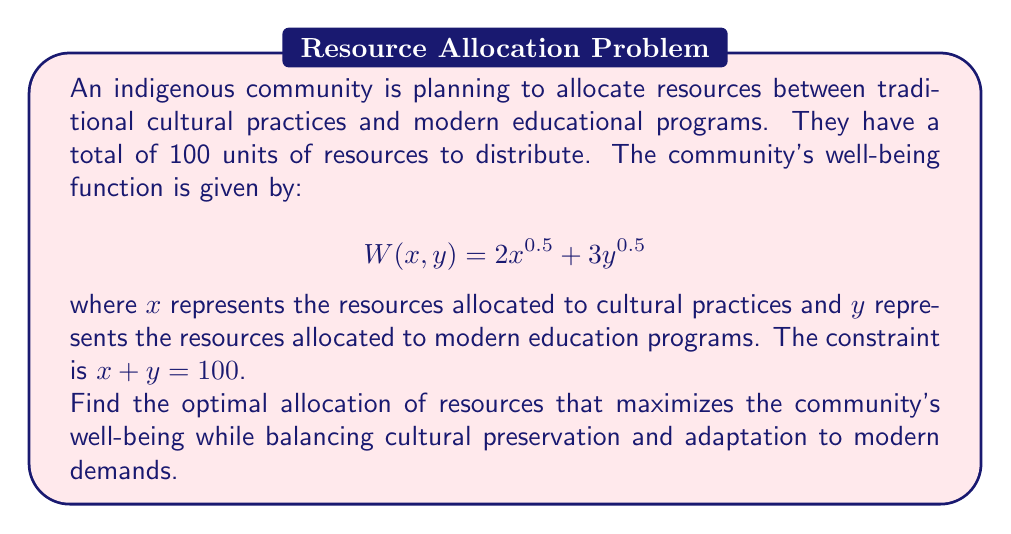Can you answer this question? To solve this optimization problem, we can use the method of Lagrange multipliers:

1. Define the Lagrangian function:
   $$L(x, y, \lambda) = 2x^{0.5} + 3y^{0.5} + \lambda(100 - x - y)$$

2. Take partial derivatives and set them equal to zero:
   $$\frac{\partial L}{\partial x} = x^{-0.5} - \lambda = 0$$
   $$\frac{\partial L}{\partial y} = \frac{3}{2}y^{-0.5} - \lambda = 0$$
   $$\frac{\partial L}{\partial \lambda} = 100 - x - y = 0$$

3. From the first two equations:
   $$x^{-0.5} = \lambda$$
   $$\frac{3}{2}y^{-0.5} = \lambda$$

4. Equate these:
   $$x^{-0.5} = \frac{3}{2}y^{-0.5}$$

5. Simplify:
   $$y = \frac{9}{4}x$$

6. Substitute into the constraint equation:
   $$x + \frac{9}{4}x = 100$$
   $$\frac{13}{4}x = 100$$
   $$x = \frac{400}{13} \approx 30.77$$

7. Calculate y:
   $$y = 100 - x = 100 - \frac{400}{13} = \frac{900}{13} \approx 69.23$$

Therefore, the optimal allocation is approximately 30.77 units to cultural practices and 69.23 units to modern education programs.
Answer: The optimal allocation is $x = \frac{400}{13} \approx 30.77$ units for cultural practices and $y = \frac{900}{13} \approx 69.23$ units for modern education programs. 